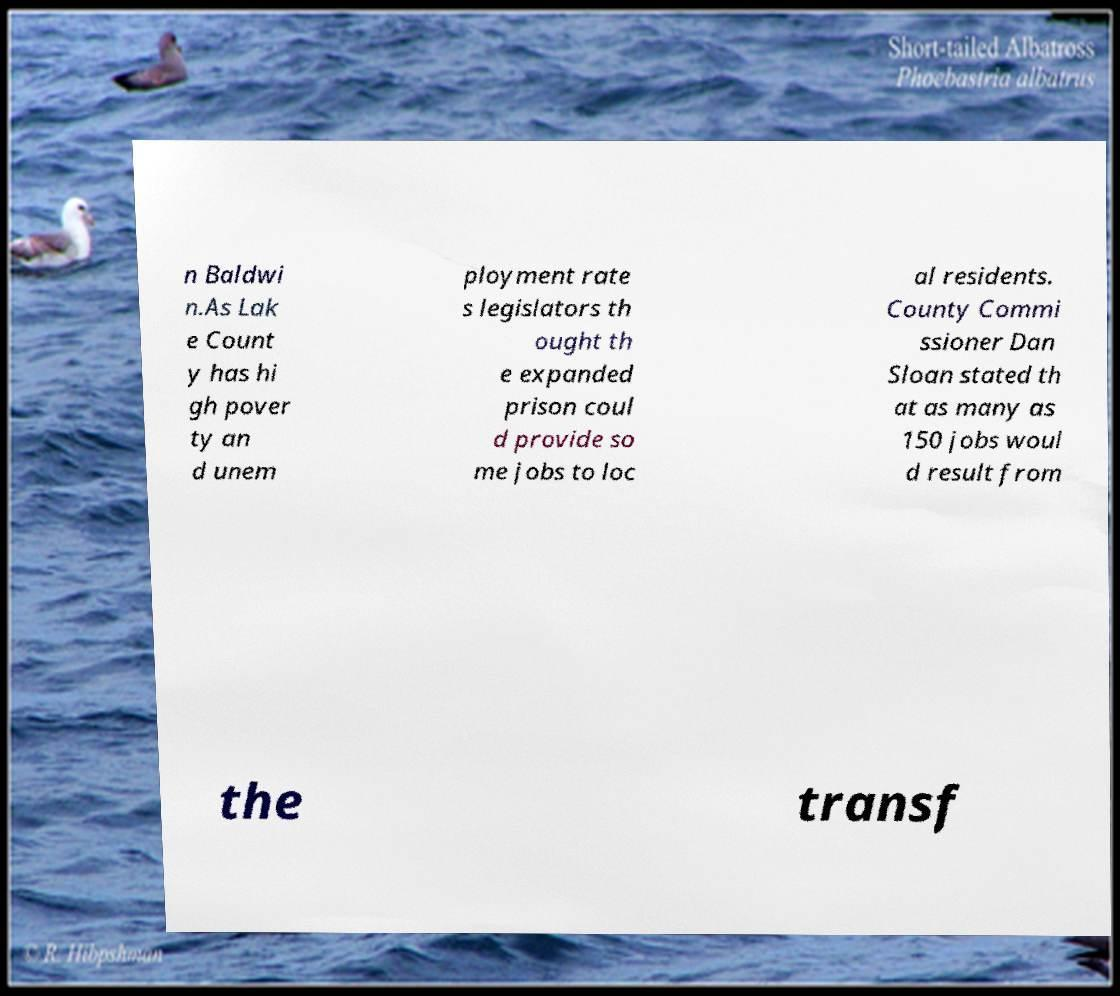Can you accurately transcribe the text from the provided image for me? n Baldwi n.As Lak e Count y has hi gh pover ty an d unem ployment rate s legislators th ought th e expanded prison coul d provide so me jobs to loc al residents. County Commi ssioner Dan Sloan stated th at as many as 150 jobs woul d result from the transf 